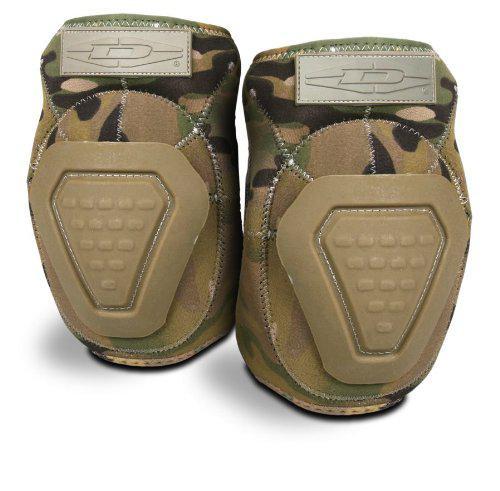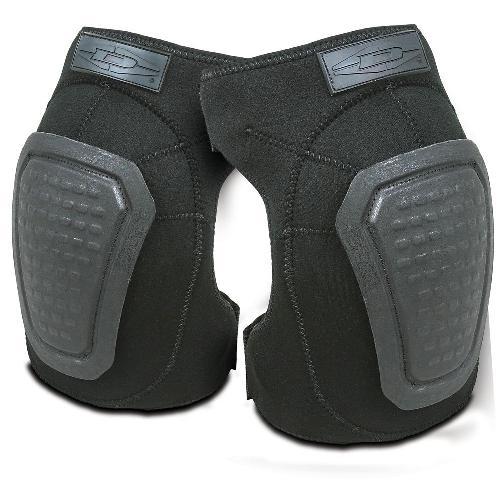The first image is the image on the left, the second image is the image on the right. Examine the images to the left and right. Is the description "The knee pads in the left image share the same design." accurate? Answer yes or no. Yes. 